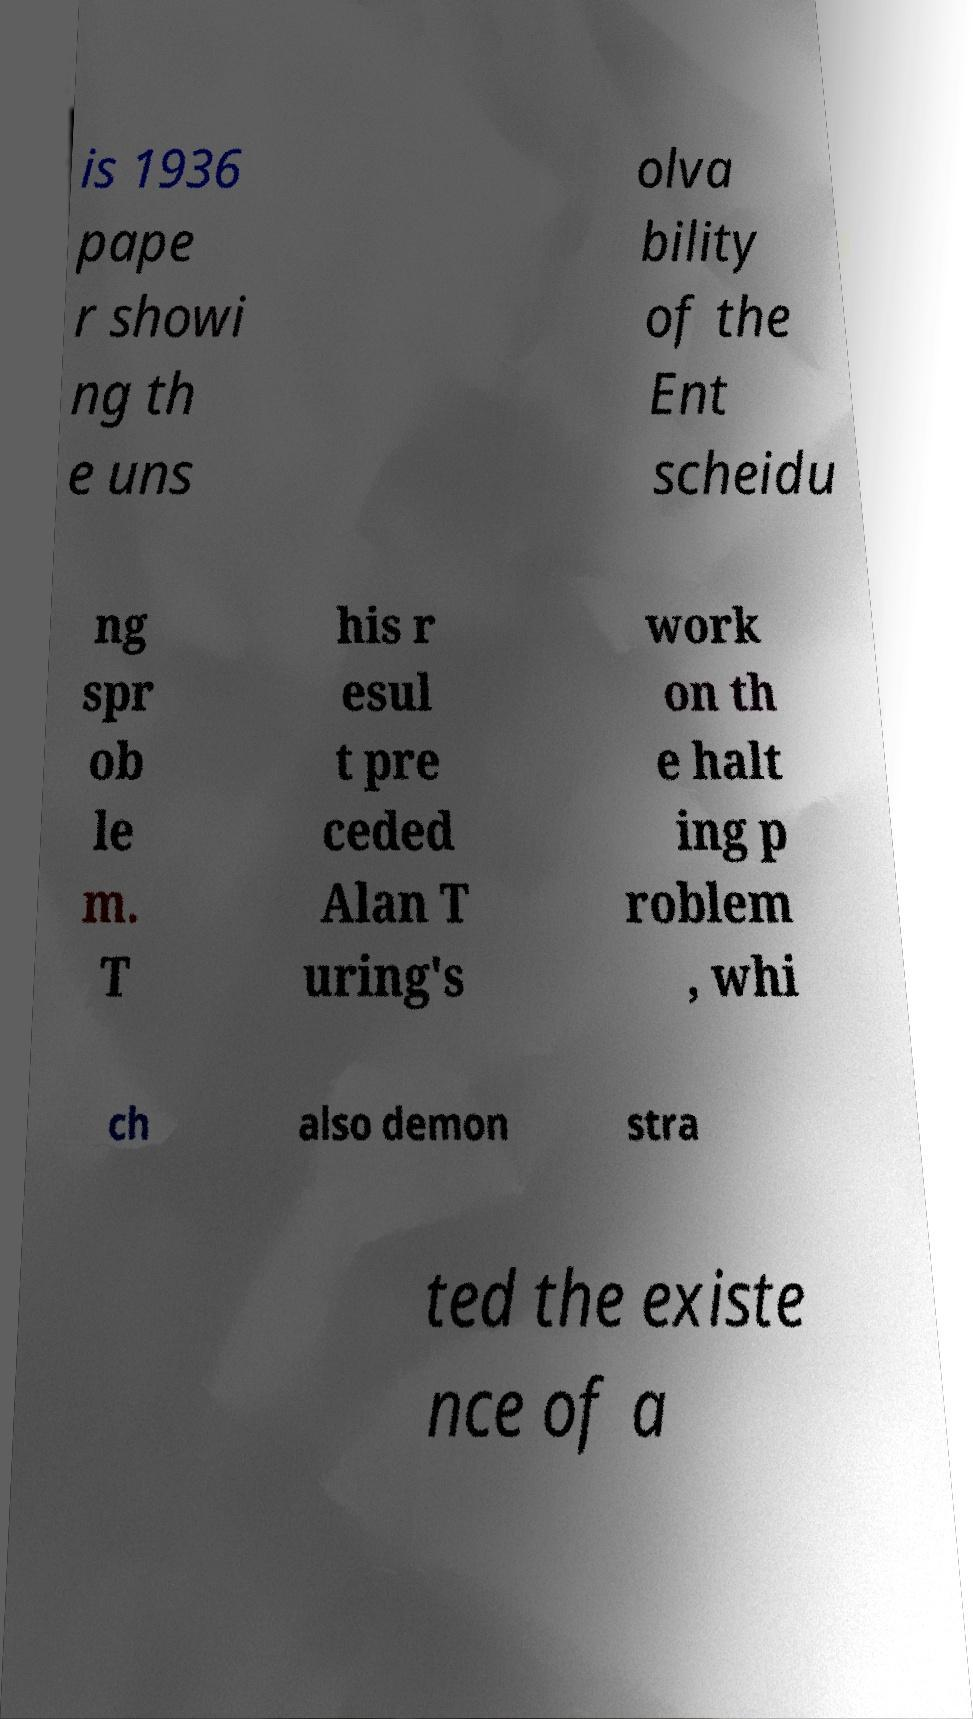Can you accurately transcribe the text from the provided image for me? is 1936 pape r showi ng th e uns olva bility of the Ent scheidu ng spr ob le m. T his r esul t pre ceded Alan T uring's work on th e halt ing p roblem , whi ch also demon stra ted the existe nce of a 